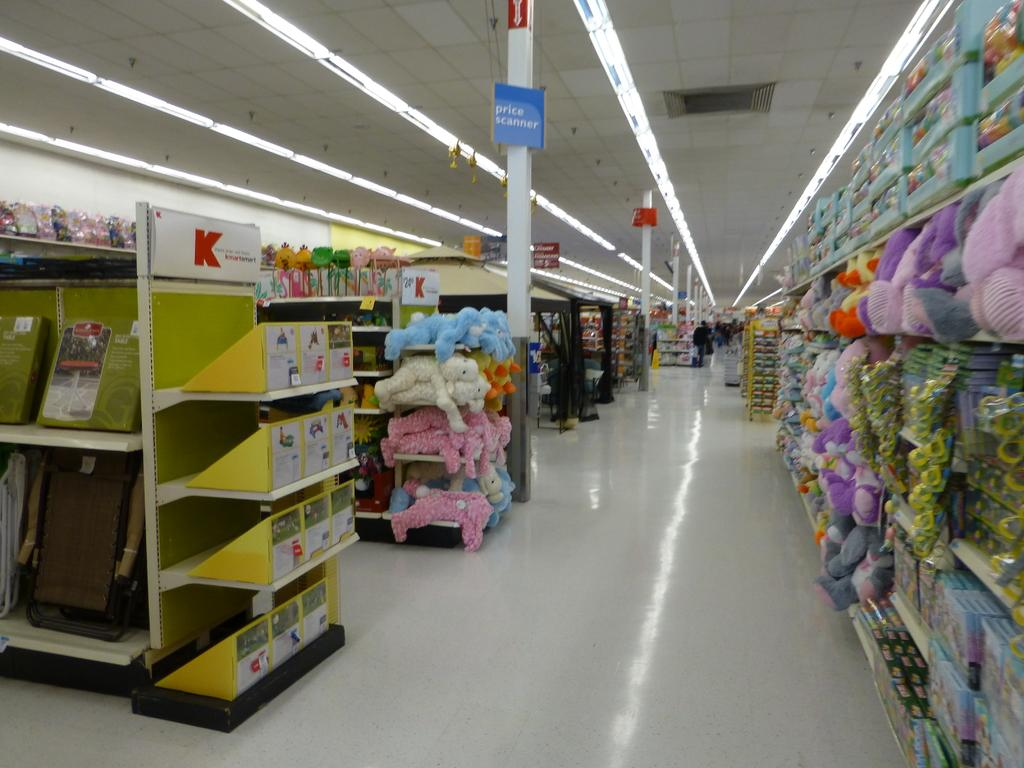What type of items can be seen in the image? There are toys in the image. Where are the objects in the image located? The objects are in racks in the image, and the racks are on the floor. What can be seen in the background of the image? There are lights visible in the background of the image. What word is being spelled out by the toys in the image? There is no word being spelled out by the toys in the image; the toys are simply placed in racks. 